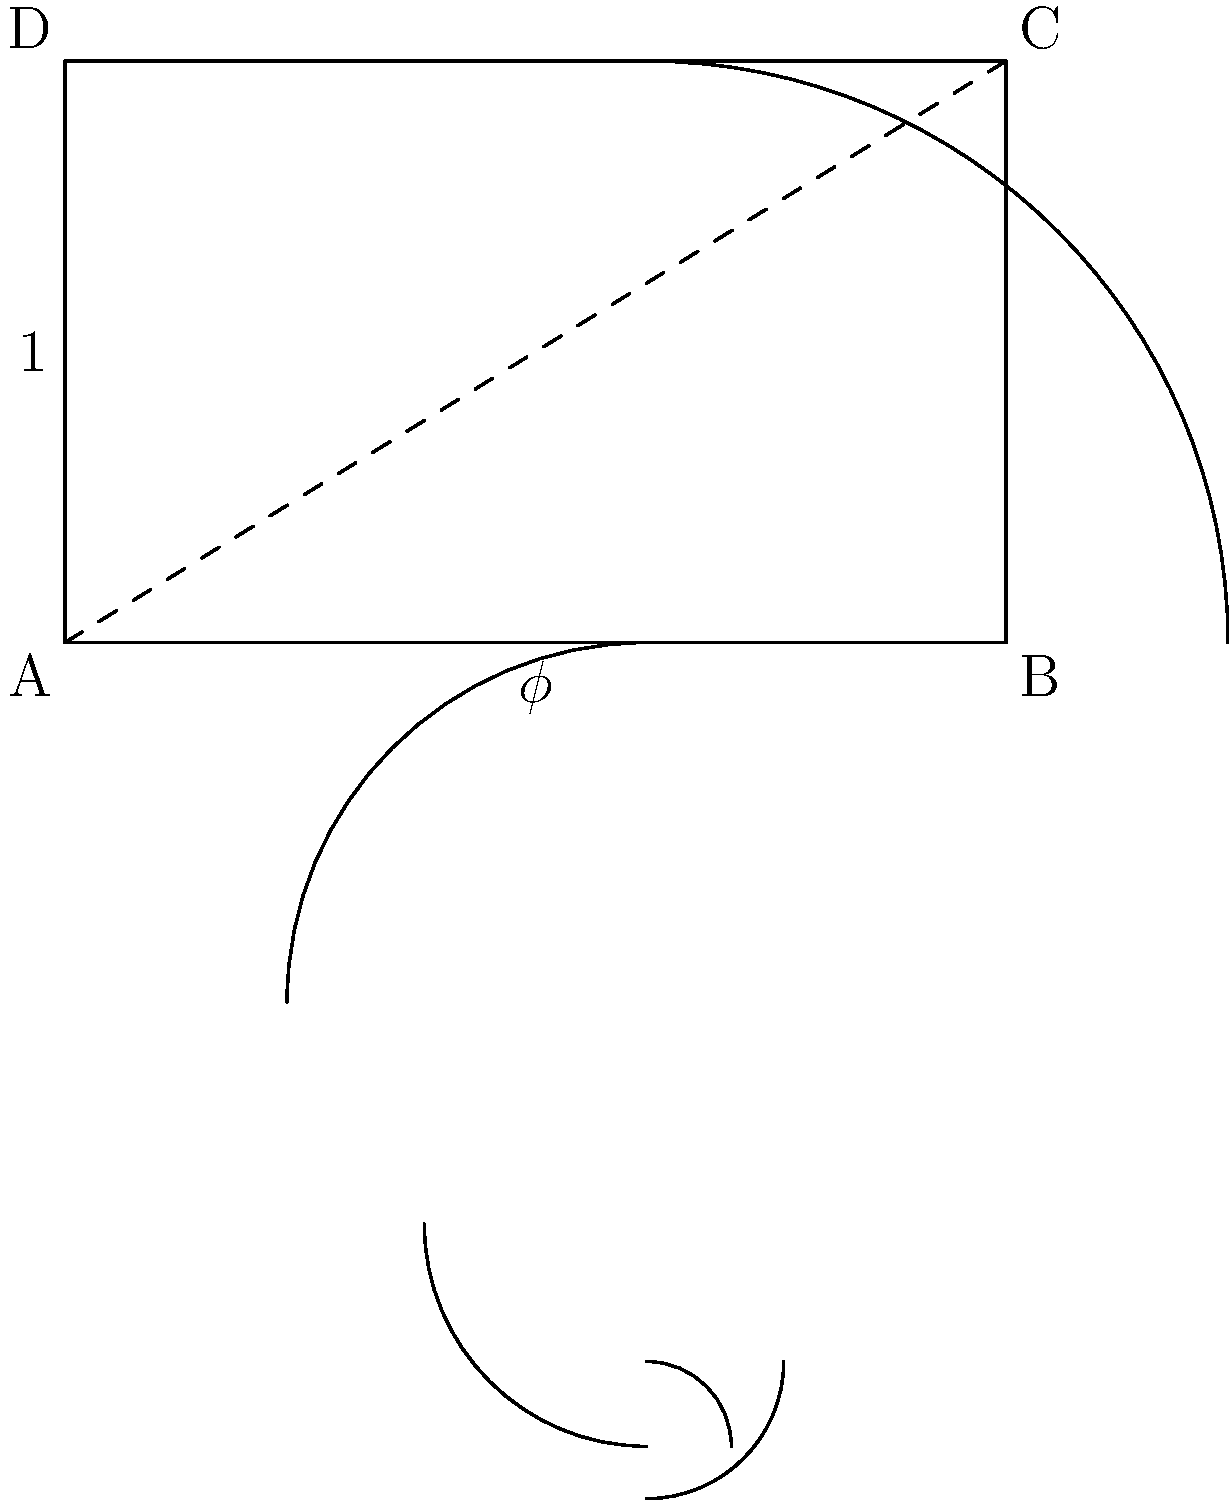In the context of Renaissance masterpieces, how does the golden ratio ($\phi$) contribute to the overall composition, and how can it be identified using geometric overlays? Provide an example of a specific Renaissance painting where this principle is evident. 1. The golden ratio ($\phi$) is approximately 1.618 and has been used in art and architecture for its aesthetically pleasing proportions.

2. In Renaissance masterpieces, the golden ratio often guides the placement of key elements within the composition:
   a. Horizontal and vertical divisions of the canvas
   b. Placement of focal points
   c. Proportions of architectural elements or human figures

3. To identify the golden ratio in a painting:
   a. Draw a golden rectangle (width:height = $\phi$:1)
   b. Divide the rectangle into a square and smaller rectangle
   c. Continue this process to create a spiral (as shown in the diagram)

4. Overlay this geometric pattern onto the painting to see if key elements align with the spiral or divisions.

5. Example: Leonardo da Vinci's "Mona Lisa"
   a. The golden rectangle aligns with her face
   b. The spiral's center point falls on her right eye
   c. The overall canvas proportions closely match the golden ratio

6. Other techniques to identify the golden ratio:
   a. Use diagonal lines to divide the canvas
   b. Look for recurring ratios of approximately 1.618:1 in various elements

7. The use of the golden ratio creates a sense of balance, harmony, and visual appeal in Renaissance compositions, reflecting the period's emphasis on mathematical proportions in art.
Answer: The golden ratio guides element placement and proportions in Renaissance paintings, identifiable through geometric overlays like spirals and rectangles (e.g., in da Vinci's "Mona Lisa"). 